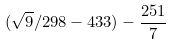<formula> <loc_0><loc_0><loc_500><loc_500>( \sqrt { 9 } / 2 9 8 - 4 3 3 ) - \frac { 2 5 1 } { 7 }</formula> 